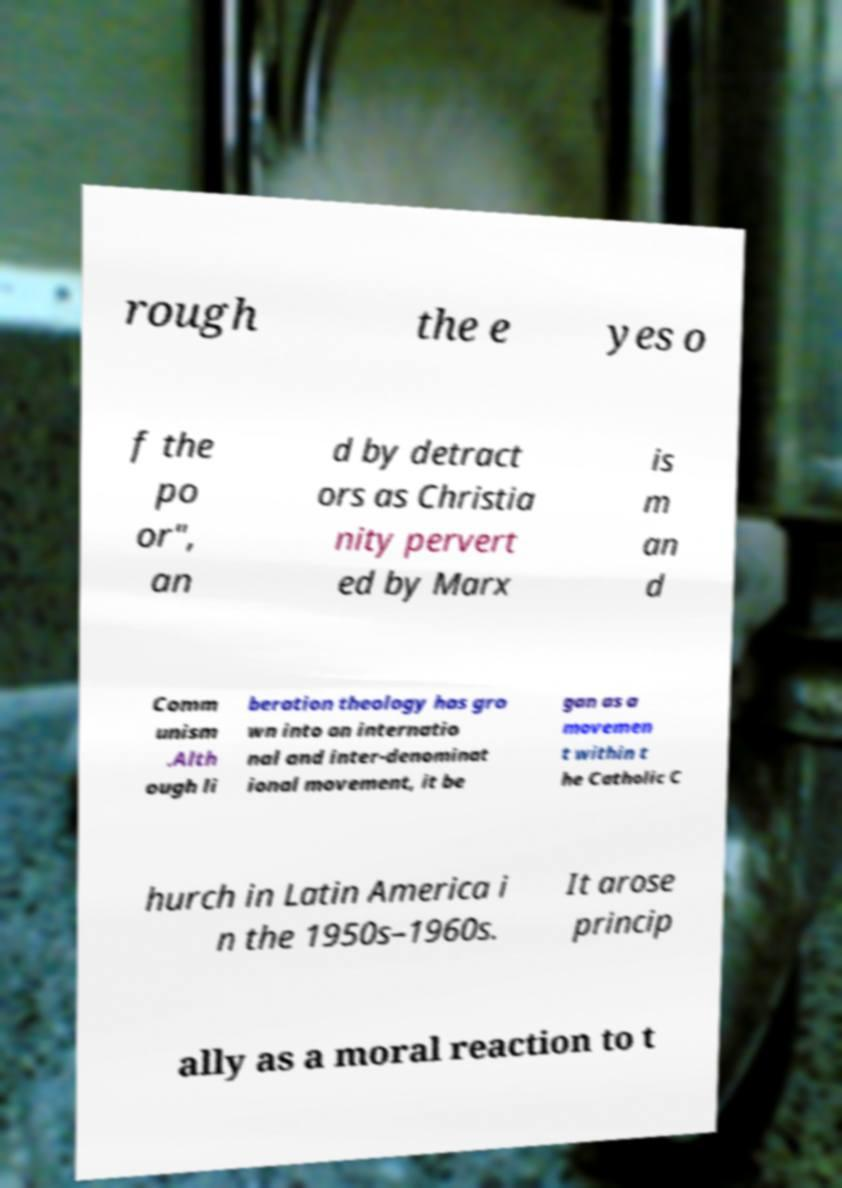For documentation purposes, I need the text within this image transcribed. Could you provide that? rough the e yes o f the po or", an d by detract ors as Christia nity pervert ed by Marx is m an d Comm unism .Alth ough li beration theology has gro wn into an internatio nal and inter-denominat ional movement, it be gan as a movemen t within t he Catholic C hurch in Latin America i n the 1950s–1960s. It arose princip ally as a moral reaction to t 